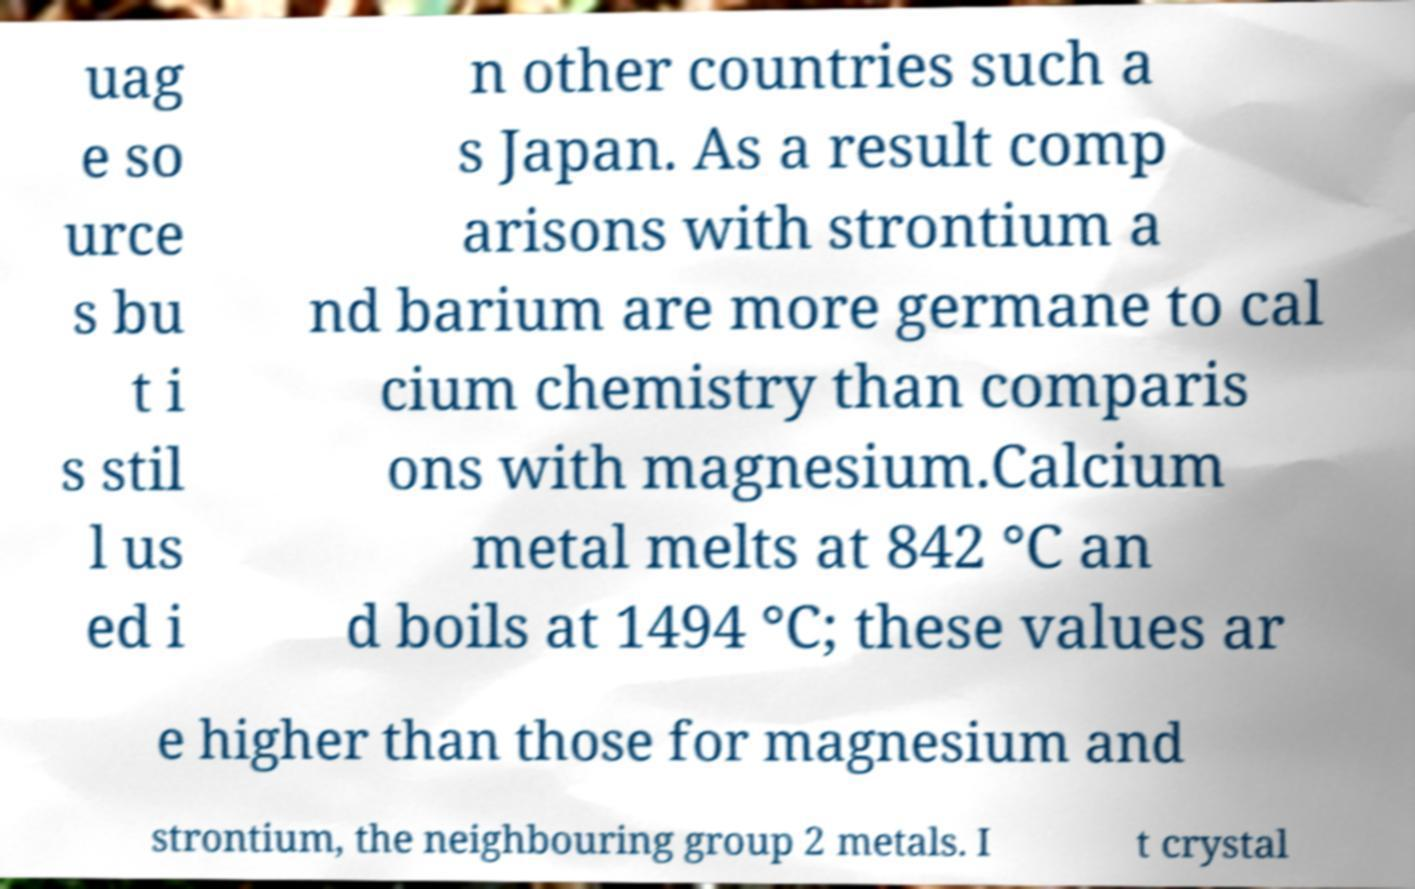Could you extract and type out the text from this image? uag e so urce s bu t i s stil l us ed i n other countries such a s Japan. As a result comp arisons with strontium a nd barium are more germane to cal cium chemistry than comparis ons with magnesium.Calcium metal melts at 842 °C an d boils at 1494 °C; these values ar e higher than those for magnesium and strontium, the neighbouring group 2 metals. I t crystal 